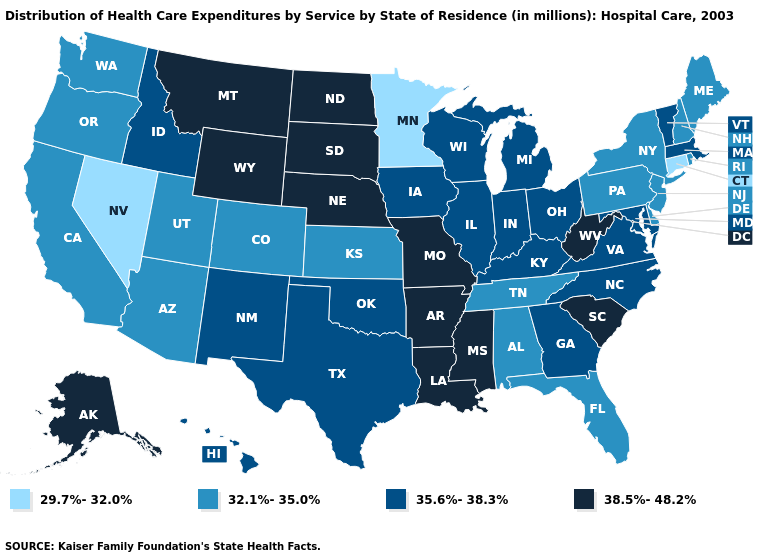Name the states that have a value in the range 35.6%-38.3%?
Write a very short answer. Georgia, Hawaii, Idaho, Illinois, Indiana, Iowa, Kentucky, Maryland, Massachusetts, Michigan, New Mexico, North Carolina, Ohio, Oklahoma, Texas, Vermont, Virginia, Wisconsin. Name the states that have a value in the range 29.7%-32.0%?
Keep it brief. Connecticut, Minnesota, Nevada. Does Utah have the lowest value in the West?
Be succinct. No. Name the states that have a value in the range 35.6%-38.3%?
Concise answer only. Georgia, Hawaii, Idaho, Illinois, Indiana, Iowa, Kentucky, Maryland, Massachusetts, Michigan, New Mexico, North Carolina, Ohio, Oklahoma, Texas, Vermont, Virginia, Wisconsin. Name the states that have a value in the range 32.1%-35.0%?
Short answer required. Alabama, Arizona, California, Colorado, Delaware, Florida, Kansas, Maine, New Hampshire, New Jersey, New York, Oregon, Pennsylvania, Rhode Island, Tennessee, Utah, Washington. What is the value of Oklahoma?
Give a very brief answer. 35.6%-38.3%. Which states hav the highest value in the South?
Answer briefly. Arkansas, Louisiana, Mississippi, South Carolina, West Virginia. Does Georgia have a lower value than Louisiana?
Concise answer only. Yes. Name the states that have a value in the range 32.1%-35.0%?
Concise answer only. Alabama, Arizona, California, Colorado, Delaware, Florida, Kansas, Maine, New Hampshire, New Jersey, New York, Oregon, Pennsylvania, Rhode Island, Tennessee, Utah, Washington. Is the legend a continuous bar?
Keep it brief. No. What is the value of Colorado?
Answer briefly. 32.1%-35.0%. Among the states that border Georgia , does Alabama have the lowest value?
Be succinct. Yes. Name the states that have a value in the range 32.1%-35.0%?
Keep it brief. Alabama, Arizona, California, Colorado, Delaware, Florida, Kansas, Maine, New Hampshire, New Jersey, New York, Oregon, Pennsylvania, Rhode Island, Tennessee, Utah, Washington. What is the value of Idaho?
Short answer required. 35.6%-38.3%. Name the states that have a value in the range 32.1%-35.0%?
Write a very short answer. Alabama, Arizona, California, Colorado, Delaware, Florida, Kansas, Maine, New Hampshire, New Jersey, New York, Oregon, Pennsylvania, Rhode Island, Tennessee, Utah, Washington. 